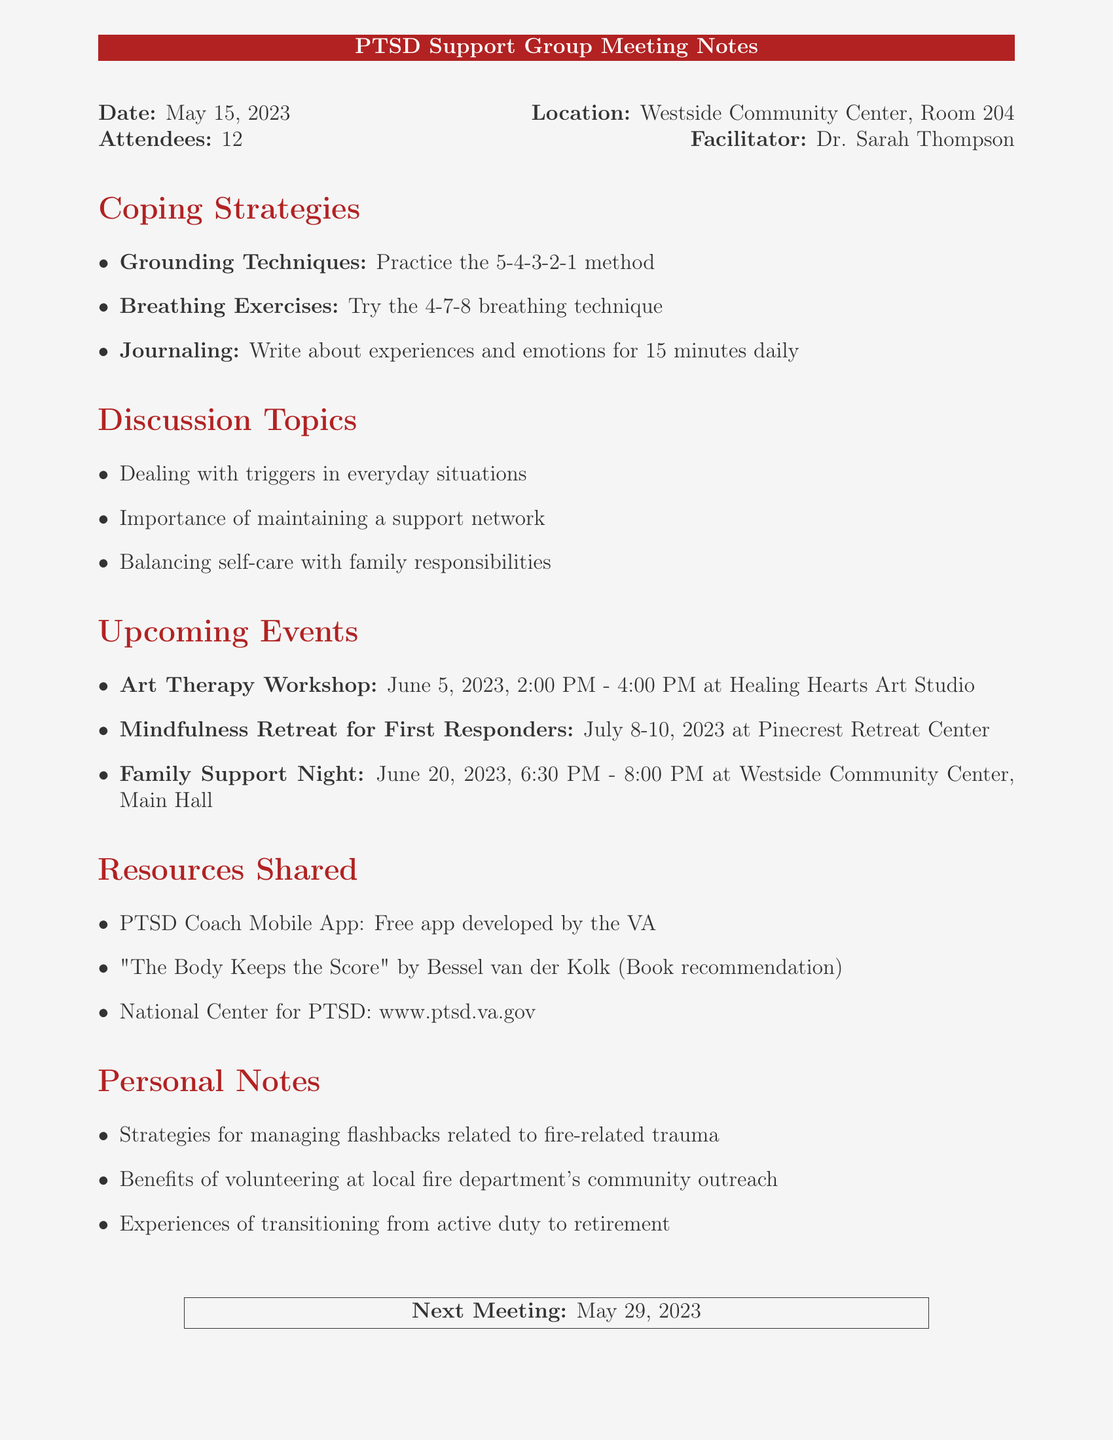what date was the meeting held? The meeting date is explicitly stated in the document.
Answer: May 15, 2023 who facilitated the meeting? The facilitator's name is mentioned at the beginning of the document.
Answer: Dr. Sarah Thompson how many attendees were present? The number of attendees is specifically listed.
Answer: 12 what is one coping strategy discussed? The coping strategies are listed in a section, and examples can be taken from there.
Answer: Grounding Techniques what is the next meeting date? The next meeting date is provided at the end of the document.
Answer: May 29, 2023 where will the Art Therapy Workshop take place? The location for the workshop is specified in the upcoming events section.
Answer: Healing Hearts Art Studio which book was recommended? The document includes a book recommendation under resources shared.
Answer: The Body Keeps the Score what is one topic discussed during the meeting? The discussion topics are listed clearly, and any of them can be used for the answer.
Answer: Dealing with triggers in everyday situations what event occurs on June 20, 2023? The events are outlined with their dates; this specific event is mentioned in the upcoming events section.
Answer: Family Support Night 